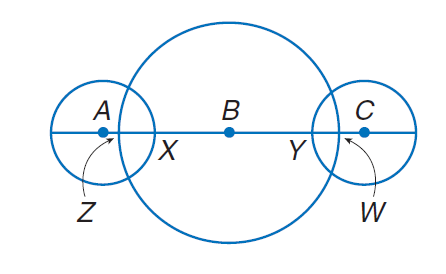Answer the mathemtical geometry problem and directly provide the correct option letter.
Question: The diameters of \odot A, \odot B, and \odot C are 10, 30 and 10 units, respectively. Find B X if A Z \cong C W and C W = 2.
Choices: A: 12 B: 24 C: 36 D: 48 A 